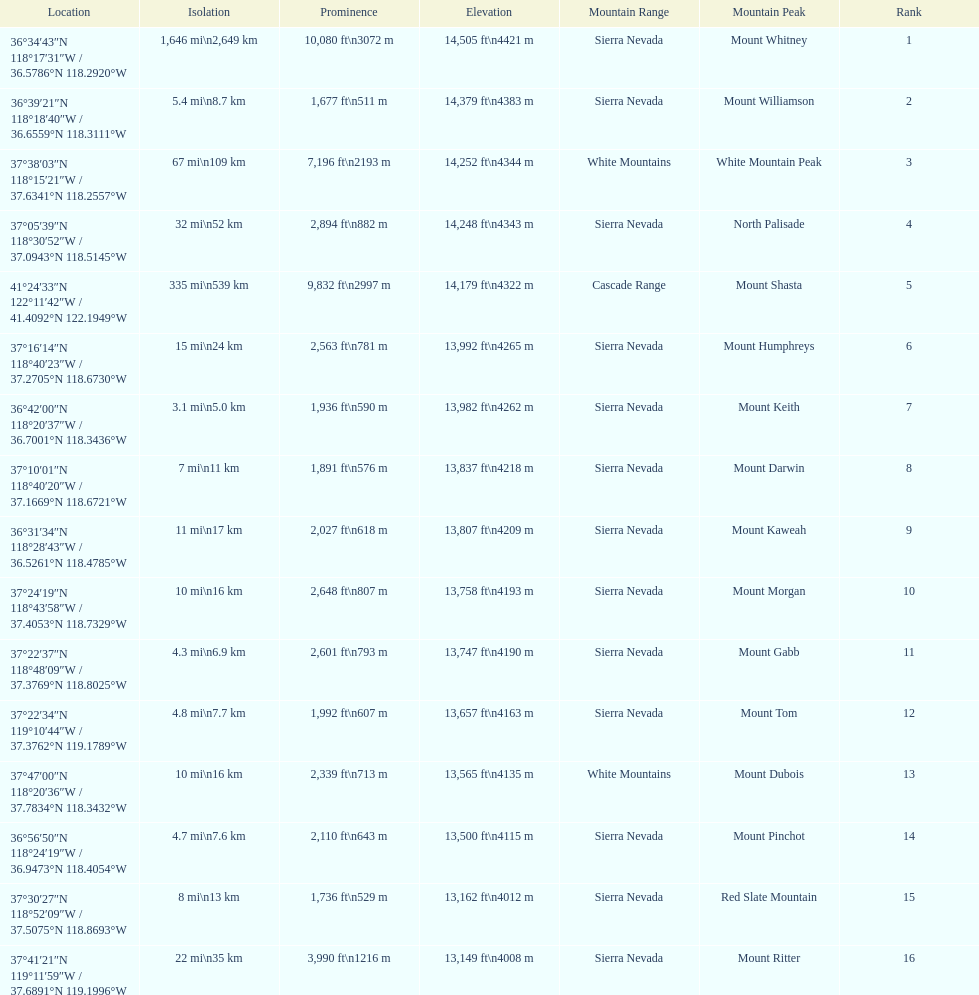Could you parse the entire table? {'header': ['Location', 'Isolation', 'Prominence', 'Elevation', 'Mountain Range', 'Mountain Peak', 'Rank'], 'rows': [['36°34′43″N 118°17′31″W\ufeff / \ufeff36.5786°N 118.2920°W', '1,646\xa0mi\\n2,649\xa0km', '10,080\xa0ft\\n3072\xa0m', '14,505\xa0ft\\n4421\xa0m', 'Sierra Nevada', 'Mount Whitney', '1'], ['36°39′21″N 118°18′40″W\ufeff / \ufeff36.6559°N 118.3111°W', '5.4\xa0mi\\n8.7\xa0km', '1,677\xa0ft\\n511\xa0m', '14,379\xa0ft\\n4383\xa0m', 'Sierra Nevada', 'Mount Williamson', '2'], ['37°38′03″N 118°15′21″W\ufeff / \ufeff37.6341°N 118.2557°W', '67\xa0mi\\n109\xa0km', '7,196\xa0ft\\n2193\xa0m', '14,252\xa0ft\\n4344\xa0m', 'White Mountains', 'White Mountain Peak', '3'], ['37°05′39″N 118°30′52″W\ufeff / \ufeff37.0943°N 118.5145°W', '32\xa0mi\\n52\xa0km', '2,894\xa0ft\\n882\xa0m', '14,248\xa0ft\\n4343\xa0m', 'Sierra Nevada', 'North Palisade', '4'], ['41°24′33″N 122°11′42″W\ufeff / \ufeff41.4092°N 122.1949°W', '335\xa0mi\\n539\xa0km', '9,832\xa0ft\\n2997\xa0m', '14,179\xa0ft\\n4322\xa0m', 'Cascade Range', 'Mount Shasta', '5'], ['37°16′14″N 118°40′23″W\ufeff / \ufeff37.2705°N 118.6730°W', '15\xa0mi\\n24\xa0km', '2,563\xa0ft\\n781\xa0m', '13,992\xa0ft\\n4265\xa0m', 'Sierra Nevada', 'Mount Humphreys', '6'], ['36°42′00″N 118°20′37″W\ufeff / \ufeff36.7001°N 118.3436°W', '3.1\xa0mi\\n5.0\xa0km', '1,936\xa0ft\\n590\xa0m', '13,982\xa0ft\\n4262\xa0m', 'Sierra Nevada', 'Mount Keith', '7'], ['37°10′01″N 118°40′20″W\ufeff / \ufeff37.1669°N 118.6721°W', '7\xa0mi\\n11\xa0km', '1,891\xa0ft\\n576\xa0m', '13,837\xa0ft\\n4218\xa0m', 'Sierra Nevada', 'Mount Darwin', '8'], ['36°31′34″N 118°28′43″W\ufeff / \ufeff36.5261°N 118.4785°W', '11\xa0mi\\n17\xa0km', '2,027\xa0ft\\n618\xa0m', '13,807\xa0ft\\n4209\xa0m', 'Sierra Nevada', 'Mount Kaweah', '9'], ['37°24′19″N 118°43′58″W\ufeff / \ufeff37.4053°N 118.7329°W', '10\xa0mi\\n16\xa0km', '2,648\xa0ft\\n807\xa0m', '13,758\xa0ft\\n4193\xa0m', 'Sierra Nevada', 'Mount Morgan', '10'], ['37°22′37″N 118°48′09″W\ufeff / \ufeff37.3769°N 118.8025°W', '4.3\xa0mi\\n6.9\xa0km', '2,601\xa0ft\\n793\xa0m', '13,747\xa0ft\\n4190\xa0m', 'Sierra Nevada', 'Mount Gabb', '11'], ['37°22′34″N 119°10′44″W\ufeff / \ufeff37.3762°N 119.1789°W', '4.8\xa0mi\\n7.7\xa0km', '1,992\xa0ft\\n607\xa0m', '13,657\xa0ft\\n4163\xa0m', 'Sierra Nevada', 'Mount Tom', '12'], ['37°47′00″N 118°20′36″W\ufeff / \ufeff37.7834°N 118.3432°W', '10\xa0mi\\n16\xa0km', '2,339\xa0ft\\n713\xa0m', '13,565\xa0ft\\n4135\xa0m', 'White Mountains', 'Mount Dubois', '13'], ['36°56′50″N 118°24′19″W\ufeff / \ufeff36.9473°N 118.4054°W', '4.7\xa0mi\\n7.6\xa0km', '2,110\xa0ft\\n643\xa0m', '13,500\xa0ft\\n4115\xa0m', 'Sierra Nevada', 'Mount Pinchot', '14'], ['37°30′27″N 118°52′09″W\ufeff / \ufeff37.5075°N 118.8693°W', '8\xa0mi\\n13\xa0km', '1,736\xa0ft\\n529\xa0m', '13,162\xa0ft\\n4012\xa0m', 'Sierra Nevada', 'Red Slate Mountain', '15'], ['37°41′21″N 119°11′59″W\ufeff / \ufeff37.6891°N 119.1996°W', '22\xa0mi\\n35\xa0km', '3,990\xa0ft\\n1216\xa0m', '13,149\xa0ft\\n4008\xa0m', 'Sierra Nevada', 'Mount Ritter', '16']]} What is the total elevation (in ft) of mount whitney? 14,505 ft. 